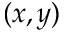<formula> <loc_0><loc_0><loc_500><loc_500>( x , y )</formula> 